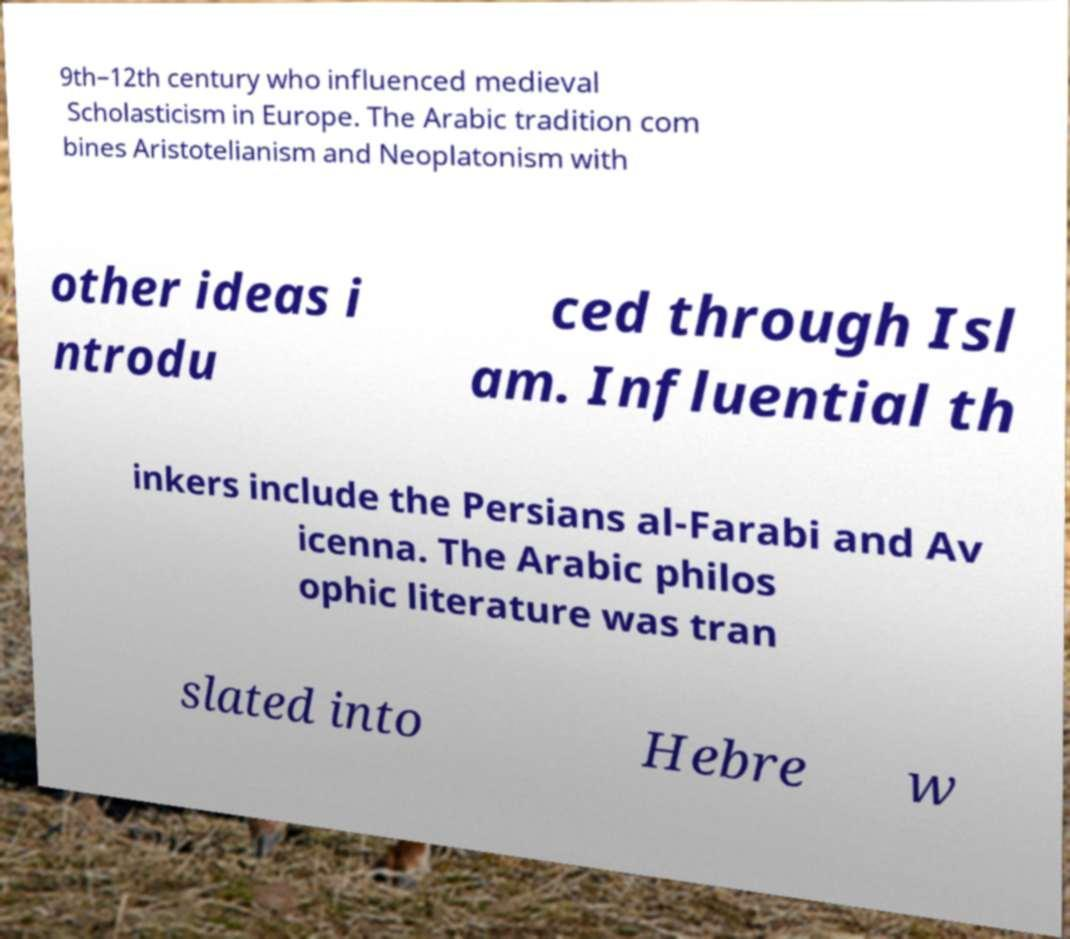What messages or text are displayed in this image? I need them in a readable, typed format. 9th–12th century who influenced medieval Scholasticism in Europe. The Arabic tradition com bines Aristotelianism and Neoplatonism with other ideas i ntrodu ced through Isl am. Influential th inkers include the Persians al-Farabi and Av icenna. The Arabic philos ophic literature was tran slated into Hebre w 